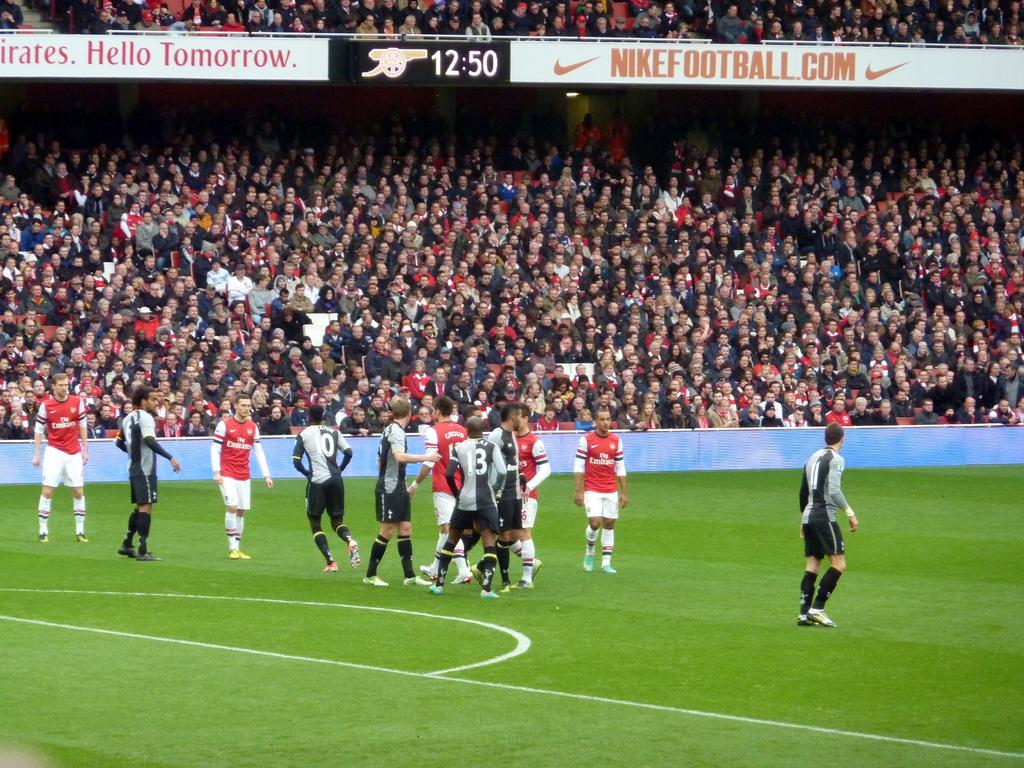Provide a one-sentence caption for the provided image. Soccer stadium that says "Nikefootball" on top and the time 12:50. 